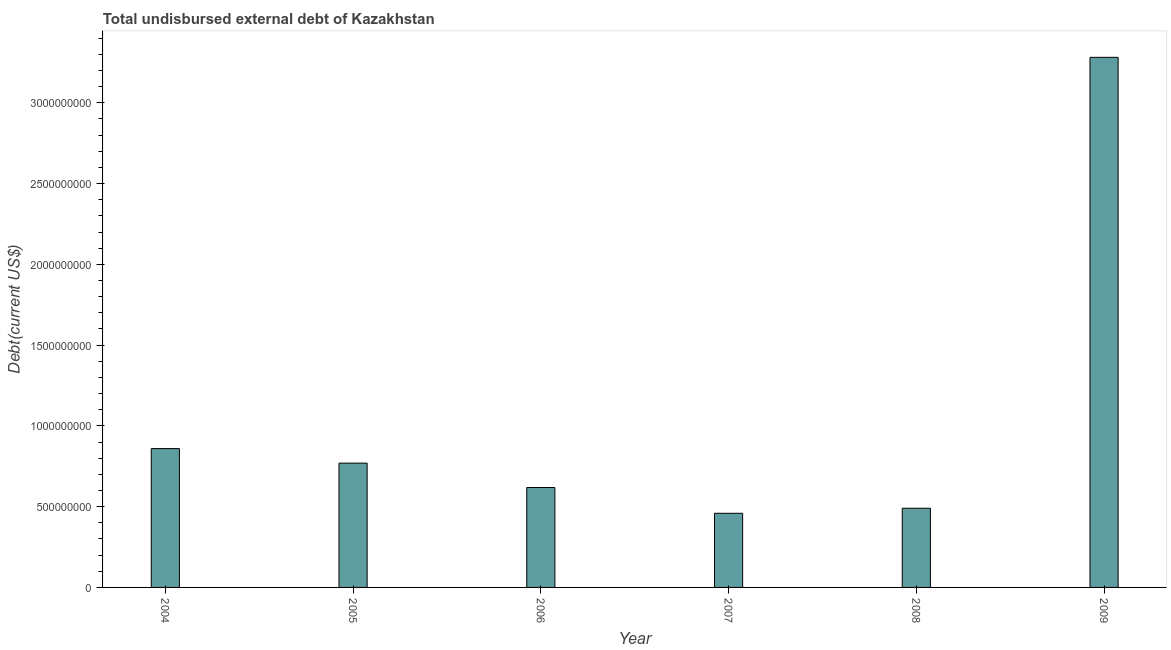Does the graph contain any zero values?
Offer a terse response. No. What is the title of the graph?
Offer a very short reply. Total undisbursed external debt of Kazakhstan. What is the label or title of the X-axis?
Give a very brief answer. Year. What is the label or title of the Y-axis?
Give a very brief answer. Debt(current US$). What is the total debt in 2005?
Your response must be concise. 7.69e+08. Across all years, what is the maximum total debt?
Ensure brevity in your answer.  3.28e+09. Across all years, what is the minimum total debt?
Keep it short and to the point. 4.59e+08. What is the sum of the total debt?
Ensure brevity in your answer.  6.48e+09. What is the difference between the total debt in 2005 and 2006?
Offer a terse response. 1.51e+08. What is the average total debt per year?
Offer a terse response. 1.08e+09. What is the median total debt?
Your answer should be compact. 6.94e+08. What is the ratio of the total debt in 2007 to that in 2009?
Your answer should be compact. 0.14. Is the total debt in 2007 less than that in 2008?
Your answer should be compact. Yes. What is the difference between the highest and the second highest total debt?
Offer a very short reply. 2.42e+09. Is the sum of the total debt in 2005 and 2009 greater than the maximum total debt across all years?
Your response must be concise. Yes. What is the difference between the highest and the lowest total debt?
Provide a short and direct response. 2.82e+09. How many bars are there?
Give a very brief answer. 6. How many years are there in the graph?
Provide a succinct answer. 6. What is the difference between two consecutive major ticks on the Y-axis?
Make the answer very short. 5.00e+08. What is the Debt(current US$) in 2004?
Your answer should be compact. 8.59e+08. What is the Debt(current US$) in 2005?
Provide a short and direct response. 7.69e+08. What is the Debt(current US$) in 2006?
Offer a very short reply. 6.18e+08. What is the Debt(current US$) of 2007?
Offer a terse response. 4.59e+08. What is the Debt(current US$) of 2008?
Give a very brief answer. 4.90e+08. What is the Debt(current US$) of 2009?
Ensure brevity in your answer.  3.28e+09. What is the difference between the Debt(current US$) in 2004 and 2005?
Make the answer very short. 9.00e+07. What is the difference between the Debt(current US$) in 2004 and 2006?
Your response must be concise. 2.41e+08. What is the difference between the Debt(current US$) in 2004 and 2007?
Keep it short and to the point. 4.00e+08. What is the difference between the Debt(current US$) in 2004 and 2008?
Ensure brevity in your answer.  3.69e+08. What is the difference between the Debt(current US$) in 2004 and 2009?
Provide a succinct answer. -2.42e+09. What is the difference between the Debt(current US$) in 2005 and 2006?
Keep it short and to the point. 1.51e+08. What is the difference between the Debt(current US$) in 2005 and 2007?
Offer a terse response. 3.11e+08. What is the difference between the Debt(current US$) in 2005 and 2008?
Your answer should be very brief. 2.79e+08. What is the difference between the Debt(current US$) in 2005 and 2009?
Keep it short and to the point. -2.51e+09. What is the difference between the Debt(current US$) in 2006 and 2007?
Make the answer very short. 1.60e+08. What is the difference between the Debt(current US$) in 2006 and 2008?
Your answer should be very brief. 1.28e+08. What is the difference between the Debt(current US$) in 2006 and 2009?
Provide a short and direct response. -2.66e+09. What is the difference between the Debt(current US$) in 2007 and 2008?
Offer a terse response. -3.13e+07. What is the difference between the Debt(current US$) in 2007 and 2009?
Give a very brief answer. -2.82e+09. What is the difference between the Debt(current US$) in 2008 and 2009?
Your answer should be compact. -2.79e+09. What is the ratio of the Debt(current US$) in 2004 to that in 2005?
Make the answer very short. 1.12. What is the ratio of the Debt(current US$) in 2004 to that in 2006?
Provide a succinct answer. 1.39. What is the ratio of the Debt(current US$) in 2004 to that in 2007?
Provide a short and direct response. 1.87. What is the ratio of the Debt(current US$) in 2004 to that in 2008?
Offer a terse response. 1.75. What is the ratio of the Debt(current US$) in 2004 to that in 2009?
Make the answer very short. 0.26. What is the ratio of the Debt(current US$) in 2005 to that in 2006?
Your response must be concise. 1.24. What is the ratio of the Debt(current US$) in 2005 to that in 2007?
Provide a succinct answer. 1.68. What is the ratio of the Debt(current US$) in 2005 to that in 2008?
Provide a short and direct response. 1.57. What is the ratio of the Debt(current US$) in 2005 to that in 2009?
Offer a terse response. 0.23. What is the ratio of the Debt(current US$) in 2006 to that in 2007?
Ensure brevity in your answer.  1.35. What is the ratio of the Debt(current US$) in 2006 to that in 2008?
Your response must be concise. 1.26. What is the ratio of the Debt(current US$) in 2006 to that in 2009?
Give a very brief answer. 0.19. What is the ratio of the Debt(current US$) in 2007 to that in 2008?
Your response must be concise. 0.94. What is the ratio of the Debt(current US$) in 2007 to that in 2009?
Your response must be concise. 0.14. What is the ratio of the Debt(current US$) in 2008 to that in 2009?
Your answer should be compact. 0.15. 